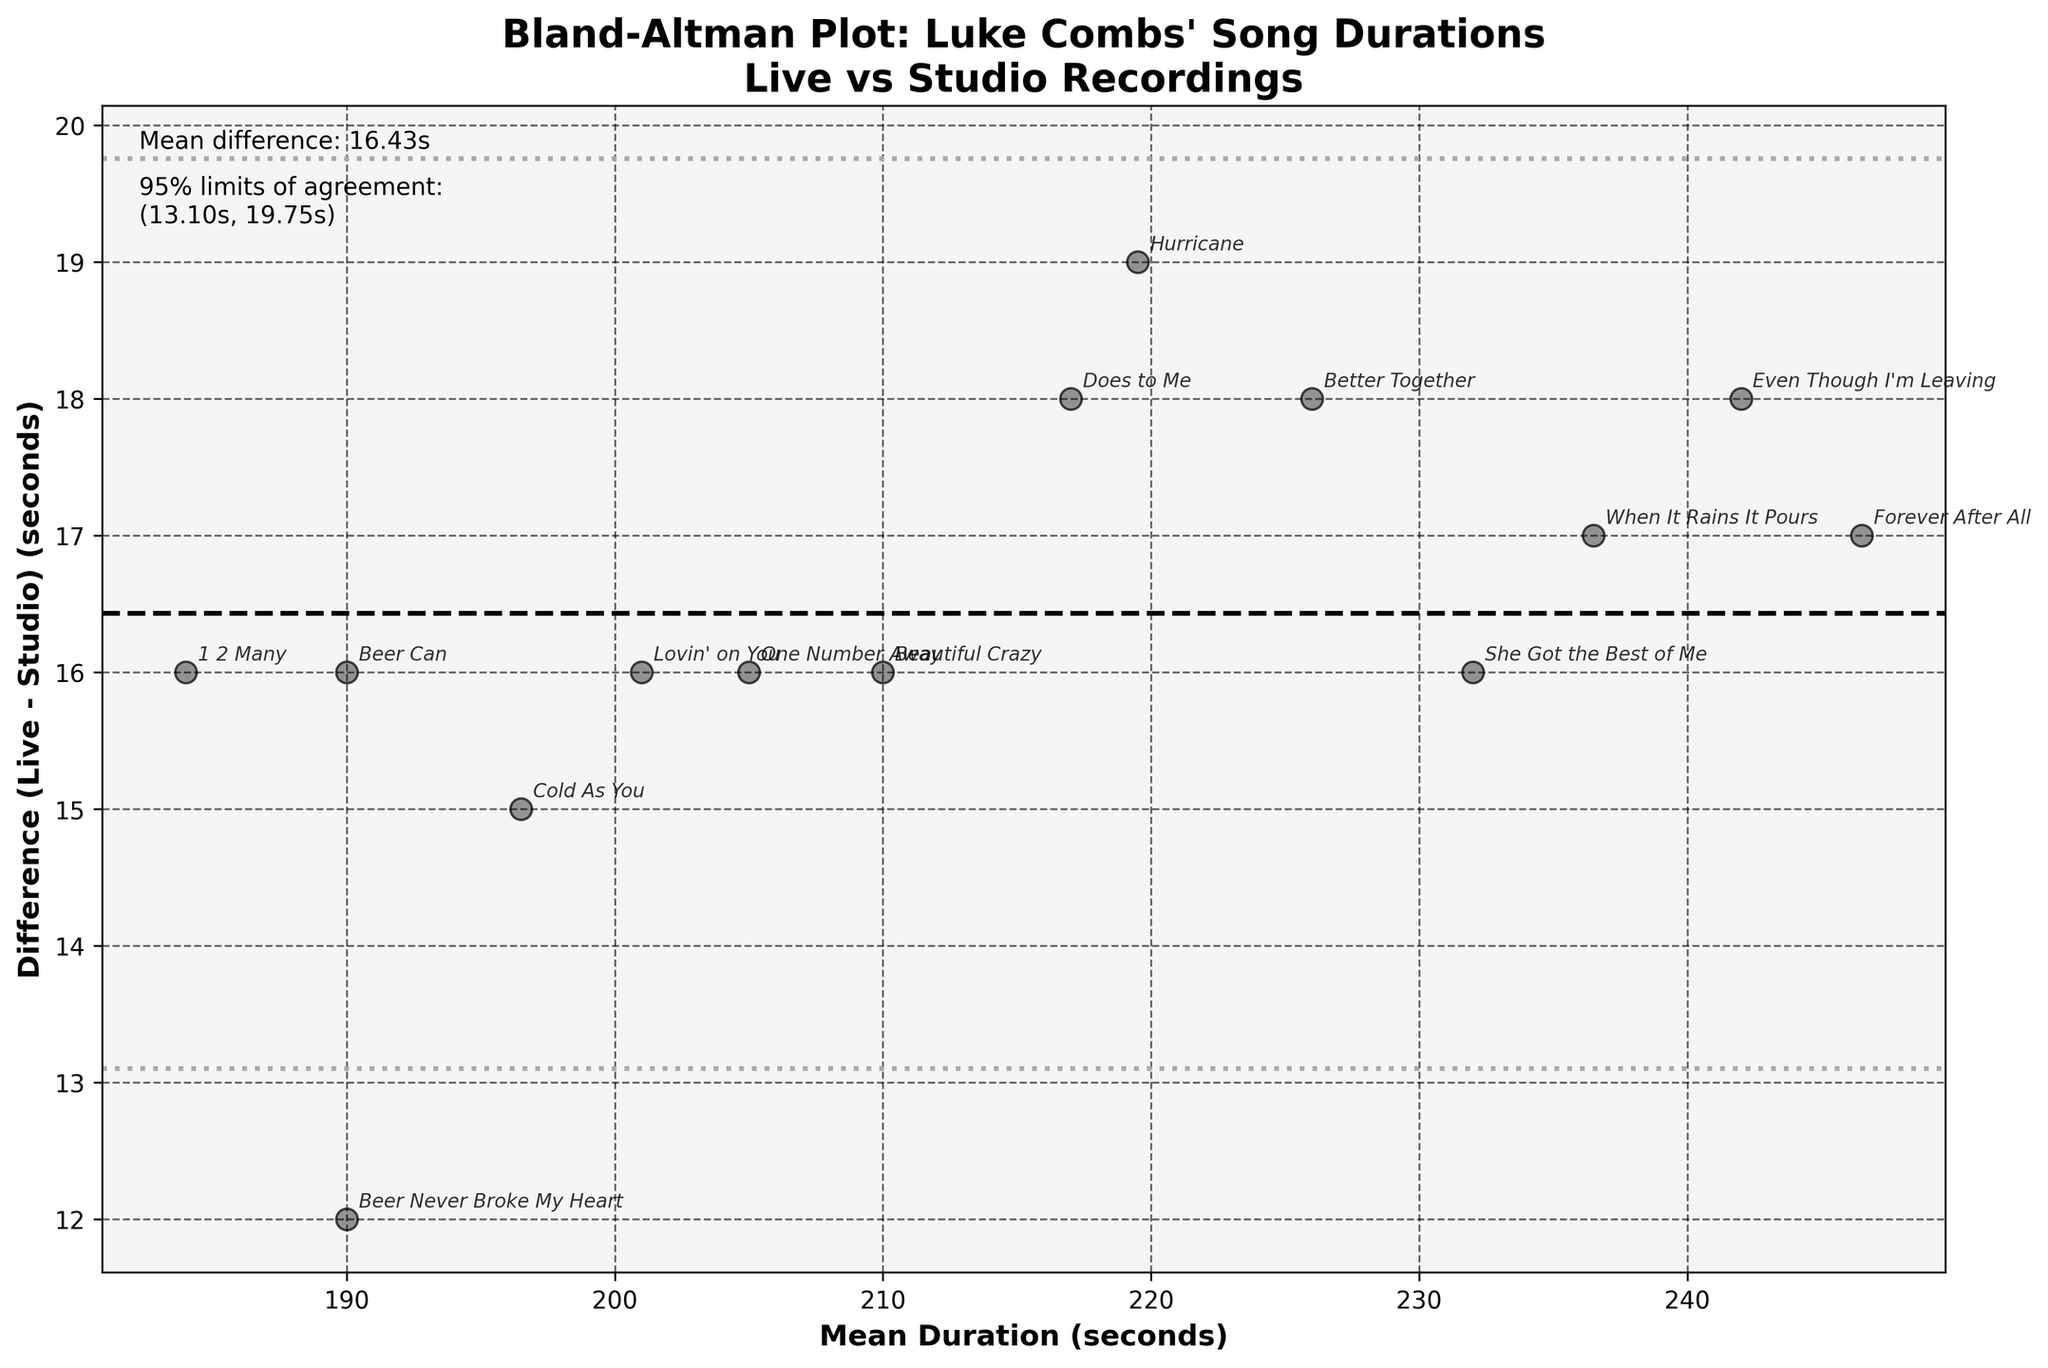How many songs by Luke Combs were included in the analysis? The scatter plot shows 14 points, each representing a song.
Answer: 14 What is the title of the Bland-Altman plot? The title of the plot is displayed at the top and reads "Bland-Altman Plot: Luke Combs' Song Durations\nLive vs Studio Recordings."
Answer: Bland-Altman Plot: Luke Combs' Song Durations\nLive vs Studio Recordings What do the horizontal lines in the plot represent? The middle dashed line represents the mean difference between live and studio durations, and the other two dotted lines represent the 95% limits of agreement (mean difference ± 1.96 times the standard deviation).
Answer: Mean difference and 95% limits of agreement What is the mean difference between the live and studio durations? The mean difference is indicated by the middle dashed horizontal line and the value is also shown in the text on the plot, which reads "Mean difference: 16.14s."
Answer: 16.14 seconds Which song has the largest positive duration difference between live and studio performances? The song “When It Rains It Pours” has the highest positive difference, as its point is the highest above the mean difference line.
Answer: When It Rains It Pours What is the range of the 95% limits of agreement for the duration differences? The 95% limits of agreement are given in the text on the plot and range from (12.40s to 19.88s).
Answer: 12.40s to 19.88s Describe the correlation between the mean durations and the differences in durations. By observing the scatter of points around the mean difference line, there doesn’t seem to be a clear increasing or decreasing trend, indicating no strong correlation between mean durations and differences.
Answer: No strong correlation What is the difference in duration for the song "Beautiful Crazy"? The specific point labeled "Beautiful Crazy" is plotted at a difference of 16 seconds (218s - 202s).
Answer: 16 seconds Are there more songs with live performances longer than studio recordings or vice versa? Since all the points are above the zero difference line, it means all live performances are longer than studio recordings.
Answer: More live performances are longer Which song shows the smallest difference between live and studio durations? "1 2 Many" has the smallest difference, as the point labeled "1 2 Many" is closest to the mean difference line.
Answer: 1 2 Many 